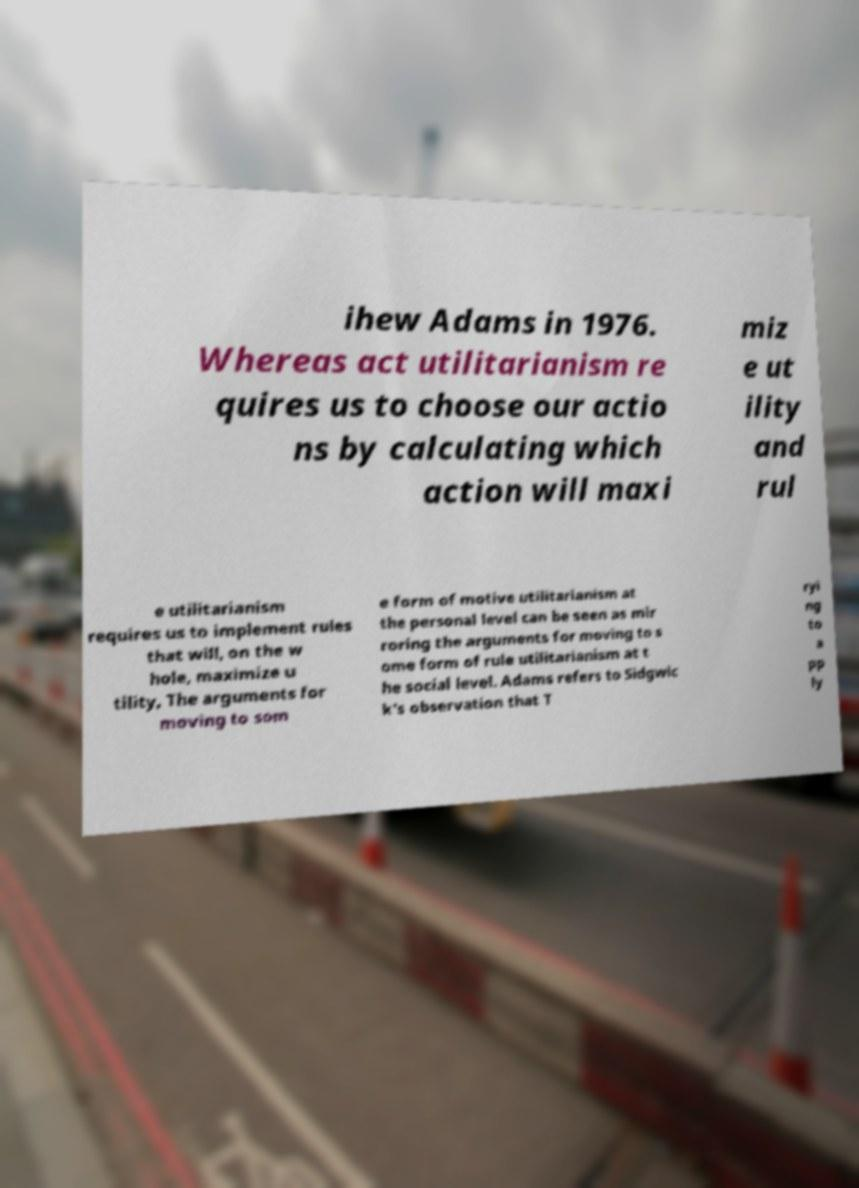Could you extract and type out the text from this image? ihew Adams in 1976. Whereas act utilitarianism re quires us to choose our actio ns by calculating which action will maxi miz e ut ility and rul e utilitarianism requires us to implement rules that will, on the w hole, maximize u tility, The arguments for moving to som e form of motive utilitarianism at the personal level can be seen as mir roring the arguments for moving to s ome form of rule utilitarianism at t he social level. Adams refers to Sidgwic k's observation that T ryi ng to a pp ly 